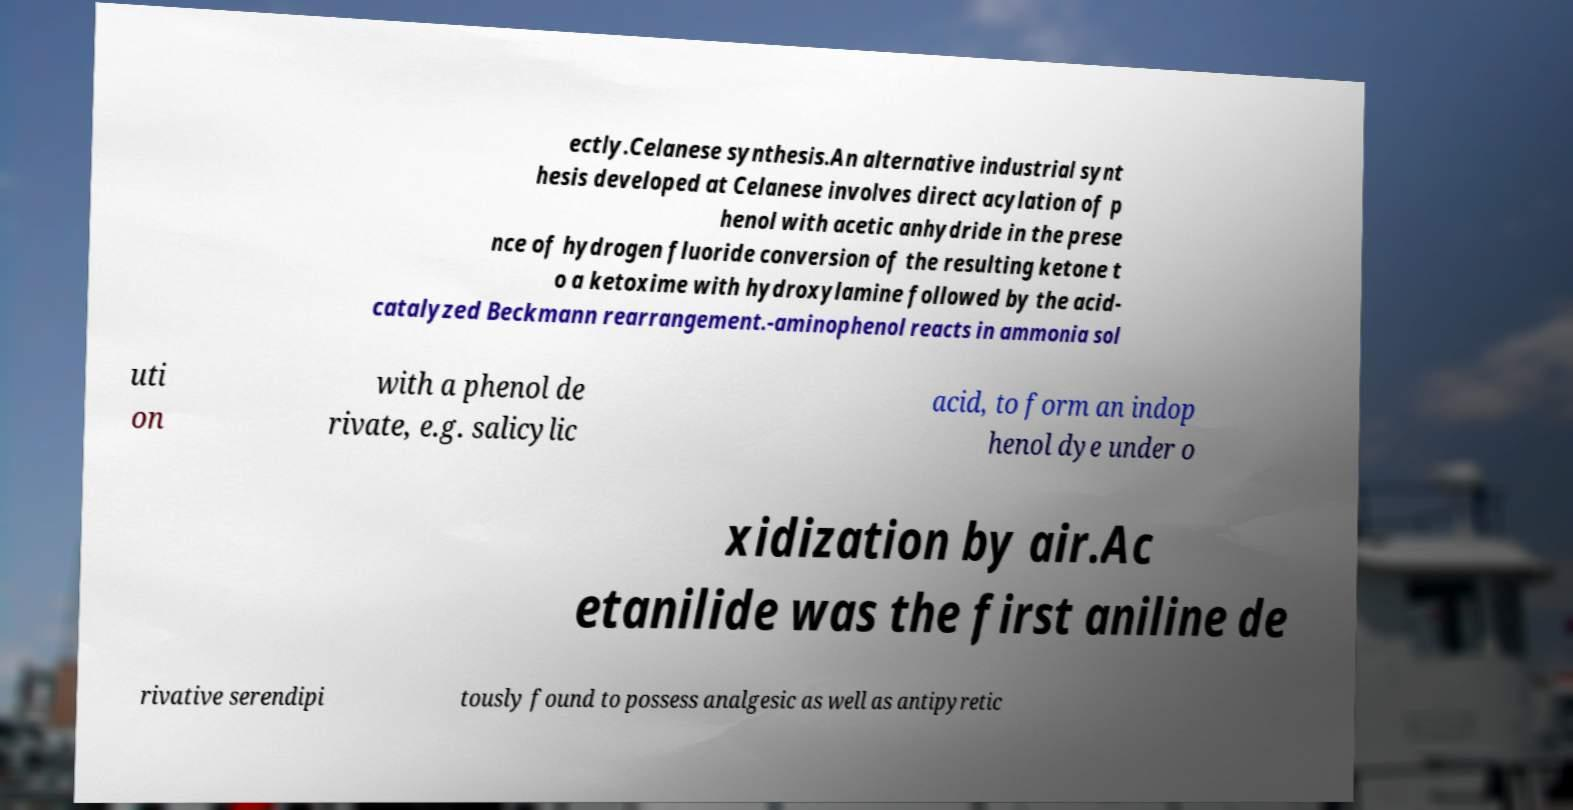Could you assist in decoding the text presented in this image and type it out clearly? ectly.Celanese synthesis.An alternative industrial synt hesis developed at Celanese involves direct acylation of p henol with acetic anhydride in the prese nce of hydrogen fluoride conversion of the resulting ketone t o a ketoxime with hydroxylamine followed by the acid- catalyzed Beckmann rearrangement.-aminophenol reacts in ammonia sol uti on with a phenol de rivate, e.g. salicylic acid, to form an indop henol dye under o xidization by air.Ac etanilide was the first aniline de rivative serendipi tously found to possess analgesic as well as antipyretic 